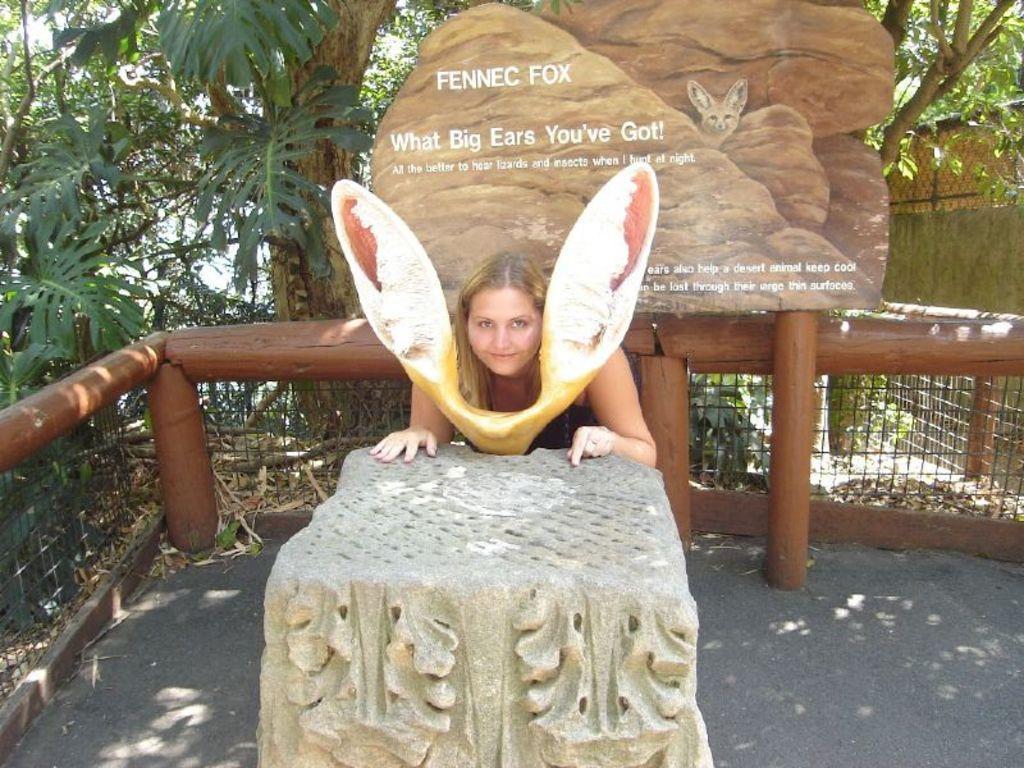Describe this image in one or two sentences. In the center of the image there is a woman and statue on the ground. In the background we can see trees, fencing, plants. 